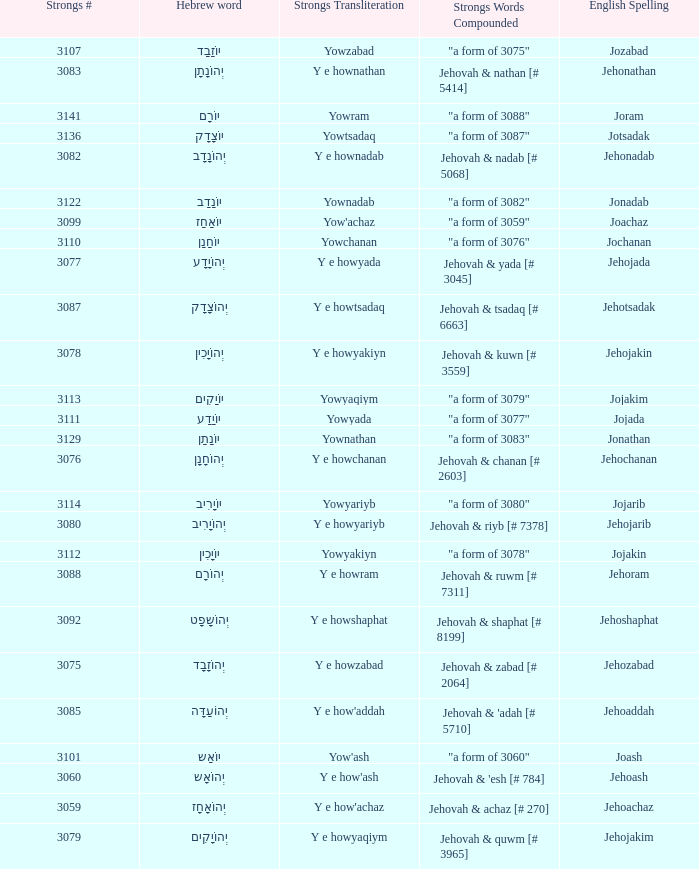What is the strongs transliteration of the hebrew word יוֹחָנָן? Yowchanan. 